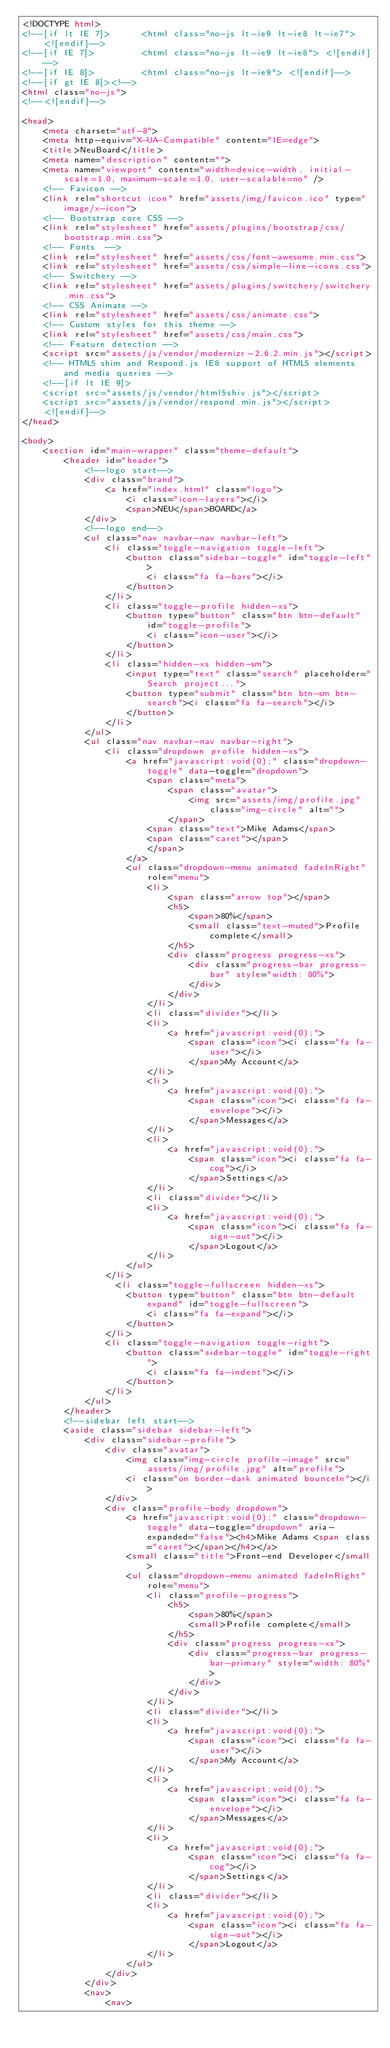Convert code to text. <code><loc_0><loc_0><loc_500><loc_500><_HTML_><!DOCTYPE html>
<!--[if lt IE 7]>      <html class="no-js lt-ie9 lt-ie8 lt-ie7"> <![endif]-->
<!--[if IE 7]>         <html class="no-js lt-ie9 lt-ie8"> <![endif]-->
<!--[if IE 8]>         <html class="no-js lt-ie9"> <![endif]-->
<!--[if gt IE 8]><!-->
<html class="no-js">
<!--<![endif]-->

<head>
    <meta charset="utf-8">
    <meta http-equiv="X-UA-Compatible" content="IE=edge">
    <title>NeuBoard</title>
    <meta name="description" content="">
    <meta name="viewport" content="width=device-width, initial-scale=1.0, maximum-scale=1.0, user-scalable=no" />
    <!-- Favicon -->
    <link rel="shortcut icon" href="assets/img/favicon.ico" type="image/x-icon">
    <!-- Bootstrap core CSS -->
    <link rel="stylesheet" href="assets/plugins/bootstrap/css/bootstrap.min.css">
    <!-- Fonts  -->
    <link rel="stylesheet" href="assets/css/font-awesome.min.css">
    <link rel="stylesheet" href="assets/css/simple-line-icons.css">
    <!-- Switchery -->
    <link rel="stylesheet" href="assets/plugins/switchery/switchery.min.css">
    <!-- CSS Animate -->
    <link rel="stylesheet" href="assets/css/animate.css">
    <!-- Custom styles for this theme -->
    <link rel="stylesheet" href="assets/css/main.css">
    <!-- Feature detection -->
    <script src="assets/js/vendor/modernizr-2.6.2.min.js"></script>
    <!-- HTML5 shim and Respond.js IE8 support of HTML5 elements and media queries -->
    <!--[if lt IE 9]>
    <script src="assets/js/vendor/html5shiv.js"></script>
    <script src="assets/js/vendor/respond.min.js"></script>
    <![endif]-->
</head>

<body>
    <section id="main-wrapper" class="theme-default">
        <header id="header">
            <!--logo start-->
            <div class="brand">
                <a href="index.html" class="logo">
                    <i class="icon-layers"></i>
                    <span>NEU</span>BOARD</a>
            </div>
            <!--logo end-->
            <ul class="nav navbar-nav navbar-left">
                <li class="toggle-navigation toggle-left">
                    <button class="sidebar-toggle" id="toggle-left">
                        <i class="fa fa-bars"></i>
                    </button>
                </li>
                <li class="toggle-profile hidden-xs">
                    <button type="button" class="btn btn-default" id="toggle-profile">
                        <i class="icon-user"></i>
                    </button>
                </li>
                <li class="hidden-xs hidden-sm">
                    <input type="text" class="search" placeholder="Search project...">
                    <button type="submit" class="btn btn-sm btn-search"><i class="fa fa-search"></i>
                    </button>
                </li>
            </ul>
            <ul class="nav navbar-nav navbar-right">
                <li class="dropdown profile hidden-xs">
                    <a href="javascript:void(0);" class="dropdown-toggle" data-toggle="dropdown">
                        <span class="meta">
                            <span class="avatar">
                                <img src="assets/img/profile.jpg" class="img-circle" alt="">
                            </span>
                        <span class="text">Mike Adams</span>
                        <span class="caret"></span>
                        </span>
                    </a>
                    <ul class="dropdown-menu animated fadeInRight" role="menu">
                        <li>
                            <span class="arrow top"></span>
                            <h5>
                                <span>80%</span>
                                <small class="text-muted">Profile complete</small>
                            </h5>
                            <div class="progress progress-xs">
                                <div class="progress-bar progress-bar" style="width: 80%">
                                </div>
                            </div>
                        </li>
                        <li class="divider"></li>
                        <li>
                            <a href="javascript:void(0);">
                                <span class="icon"><i class="fa fa-user"></i>
                                </span>My Account</a>
                        </li>
                        <li>
                            <a href="javascript:void(0);">
                                <span class="icon"><i class="fa fa-envelope"></i>
                                </span>Messages</a>
                        </li>
                        <li>
                            <a href="javascript:void(0);">
                                <span class="icon"><i class="fa fa-cog"></i>
                                </span>Settings</a>
                        </li>
                        <li class="divider"></li>
                        <li>
                            <a href="javascript:void(0);">
                                <span class="icon"><i class="fa fa-sign-out"></i>
                                </span>Logout</a>
                        </li>
                    </ul>
                </li>
                  <li class="toggle-fullscreen hidden-xs">
                    <button type="button" class="btn btn-default expand" id="toggle-fullscreen">
                        <i class="fa fa-expand"></i>
                    </button>
                </li>
                <li class="toggle-navigation toggle-right">
                    <button class="sidebar-toggle" id="toggle-right">
                        <i class="fa fa-indent"></i>
                    </button>
                </li>
            </ul>
        </header>
        <!--sidebar left start-->
        <aside class="sidebar sidebar-left">
            <div class="sidebar-profile">
                <div class="avatar">
                    <img class="img-circle profile-image" src="assets/img/profile.jpg" alt="profile">
                    <i class="on border-dark animated bounceIn"></i>
                </div>
                <div class="profile-body dropdown">
                    <a href="javascript:void(0);" class="dropdown-toggle" data-toggle="dropdown" aria-expanded="false"><h4>Mike Adams <span class="caret"></span></h4></a>
                    <small class="title">Front-end Developer</small>
                    <ul class="dropdown-menu animated fadeInRight" role="menu">
                        <li class="profile-progress">
                            <h5>
                                <span>80%</span>
                                <small>Profile complete</small>
                            </h5>
                            <div class="progress progress-xs">
                                <div class="progress-bar progress-bar-primary" style="width: 80%">
                                </div>
                            </div>
                        </li>
                        <li class="divider"></li>
                        <li>
                            <a href="javascript:void(0);">
                                <span class="icon"><i class="fa fa-user"></i>
                                </span>My Account</a>
                        </li>
                        <li>
                            <a href="javascript:void(0);">
                                <span class="icon"><i class="fa fa-envelope"></i>
                                </span>Messages</a>
                        </li>
                        <li>
                            <a href="javascript:void(0);">
                                <span class="icon"><i class="fa fa-cog"></i>
                                </span>Settings</a>
                        </li>
                        <li class="divider"></li>
                        <li>
                            <a href="javascript:void(0);">
                                <span class="icon"><i class="fa fa-sign-out"></i>
                                </span>Logout</a>
                        </li>
                    </ul>
                </div>
            </div>
            <nav>
                <nav></code> 